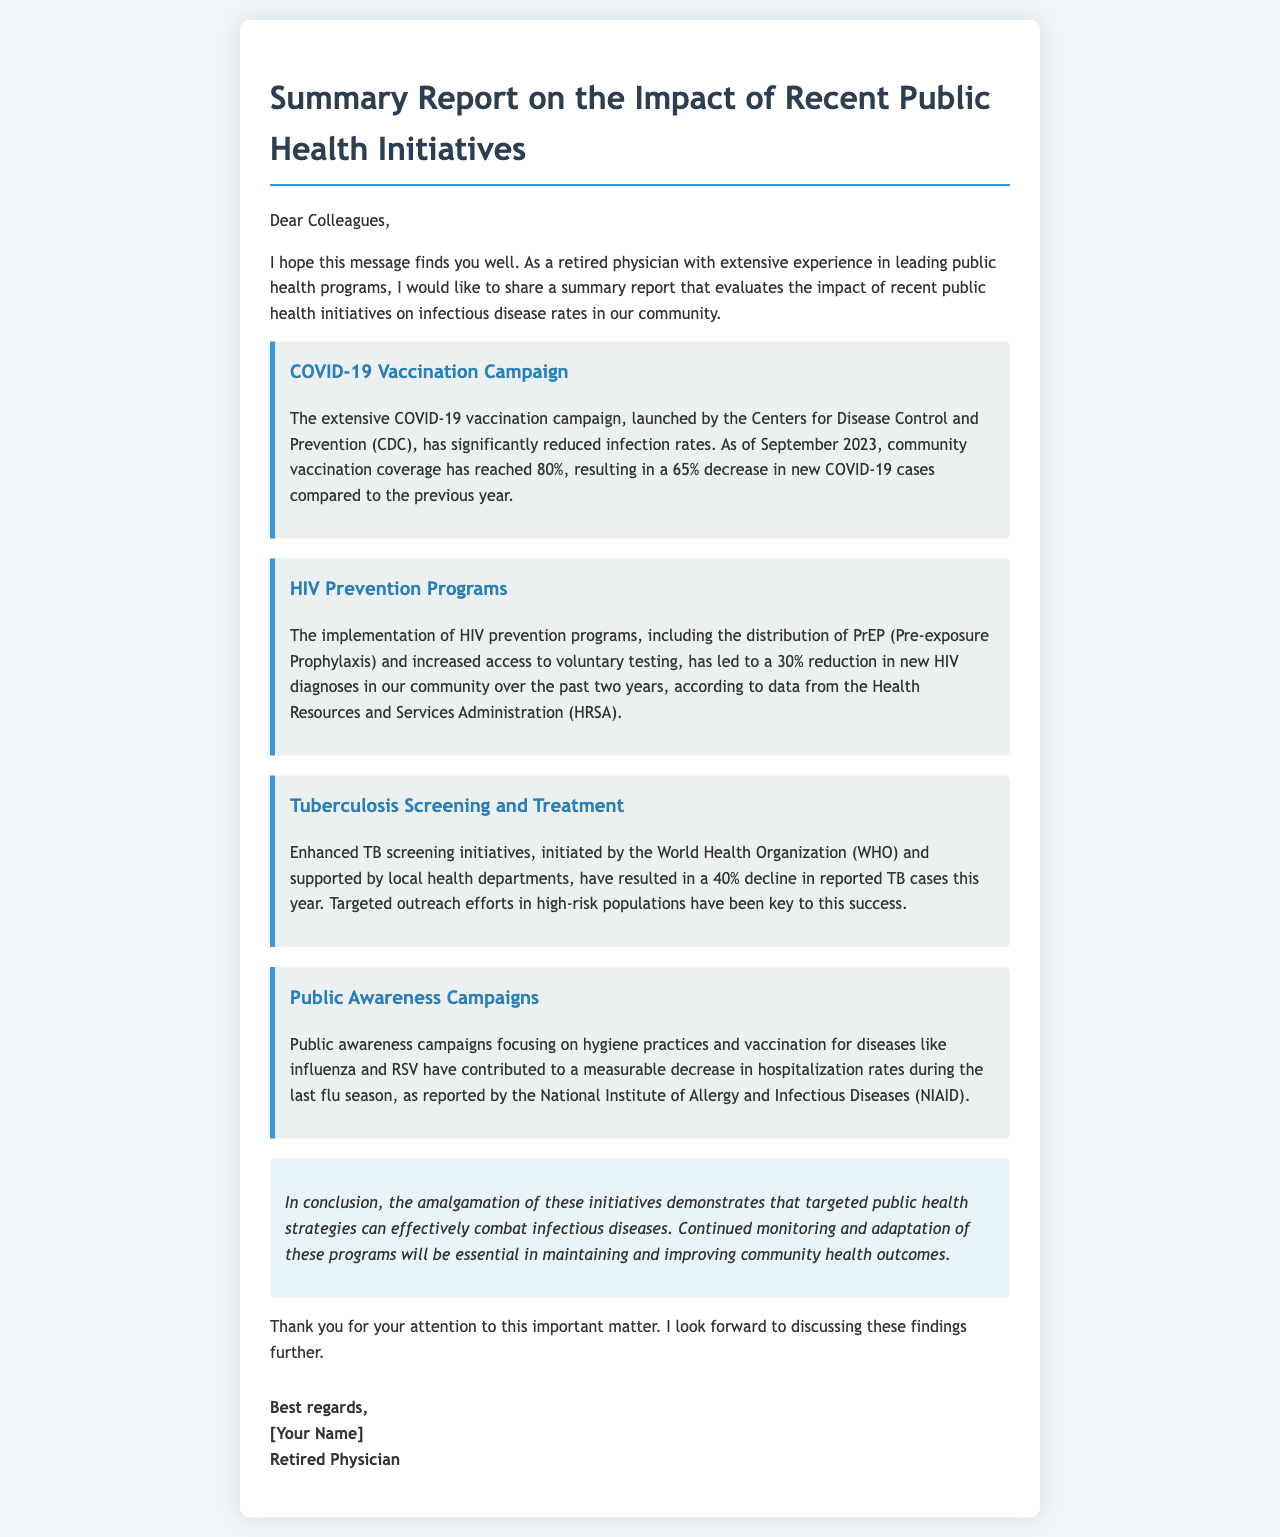What was the vaccination coverage for COVID-19 as of September 2023? The document states that community vaccination coverage has reached 80% for COVID-19 as of September 2023.
Answer: 80% What percentage decrease in new COVID-19 cases was reported? According to the report, there has been a 65% decrease in new COVID-19 cases compared to the previous year.
Answer: 65% What is the reduction percentage in new HIV diagnoses? The document mentions a 30% reduction in new HIV diagnoses over the past two years due to the HIV prevention programs.
Answer: 30% Which organization supports tuberculosis screening initiatives? The World Health Organization (WHO) initiated the enhanced TB screening initiatives as mentioned in the document.
Answer: World Health Organization What was the decline percentage in reported TB cases this year? A 40% decline in reported TB cases has been reported this year due to enhanced TB screening initiatives.
Answer: 40% What types of diseases were the public awareness campaigns focusing on? The campaigns targeted hygiene practices and vaccination for diseases like influenza and RSV, according to the document.
Answer: Influenza and RSV What is the overall conclusion regarding the public health initiatives? The conclusion highlights that targeted public health strategies can effectively combat infectious diseases.
Answer: Effectively combat infectious diseases Who authored the report? The email concludes with a signature indicating the author's title as a "Retired Physician."
Answer: Retired Physician 